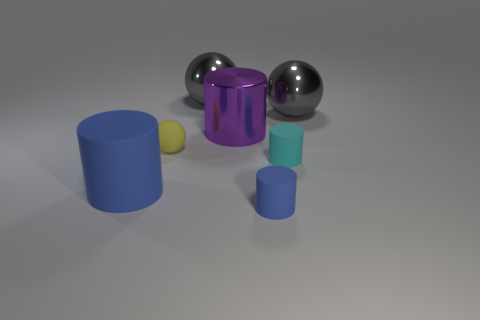Subtract all gray spheres. How many spheres are left? 1 Add 1 big gray shiny things. How many objects exist? 8 Subtract all gray spheres. How many spheres are left? 1 Subtract all cylinders. How many objects are left? 3 Subtract 2 spheres. How many spheres are left? 1 Add 5 tiny blue cylinders. How many tiny blue cylinders exist? 6 Subtract 1 yellow balls. How many objects are left? 6 Subtract all green cylinders. Subtract all gray spheres. How many cylinders are left? 4 Subtract all cyan spheres. How many blue cylinders are left? 2 Subtract all cyan rubber objects. Subtract all tiny yellow objects. How many objects are left? 5 